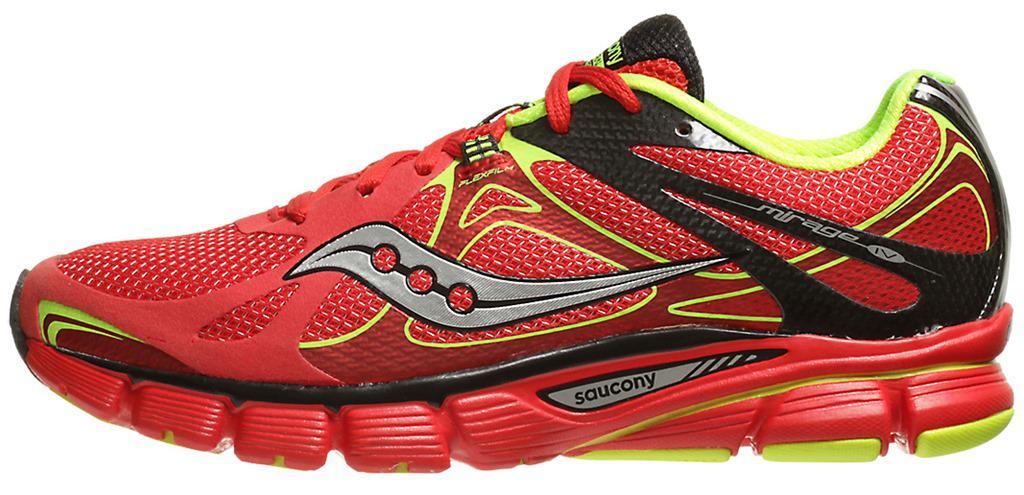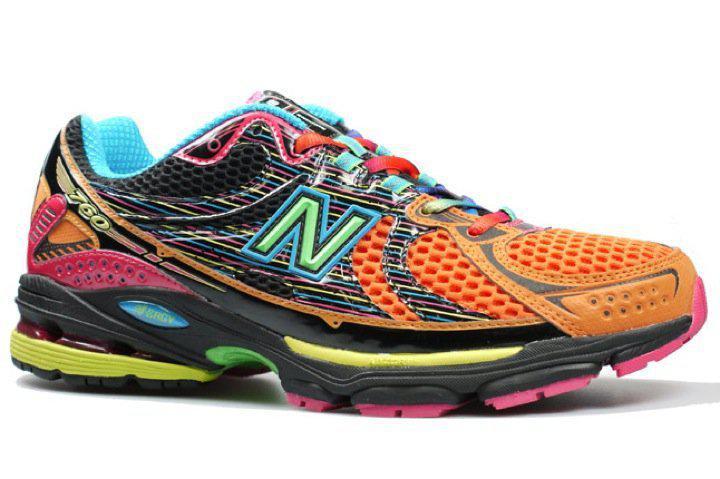The first image is the image on the left, the second image is the image on the right. Given the left and right images, does the statement "Each image contains a single sneaker, and the sneakers in the left and right images face different [left vs right] directions." hold true? Answer yes or no. Yes. The first image is the image on the left, the second image is the image on the right. Analyze the images presented: Is the assertion "A single shoe sits on a white surface in each of the images." valid? Answer yes or no. Yes. 